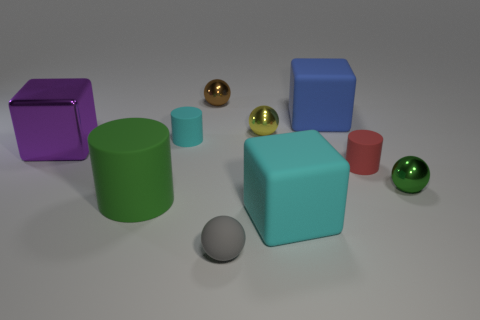Subtract all green spheres. How many spheres are left? 3 Subtract all cyan spheres. Subtract all green cylinders. How many spheres are left? 4 Subtract all blocks. How many objects are left? 7 Subtract 1 green cylinders. How many objects are left? 9 Subtract all red rubber balls. Subtract all tiny cyan things. How many objects are left? 9 Add 6 yellow balls. How many yellow balls are left? 7 Add 2 cubes. How many cubes exist? 5 